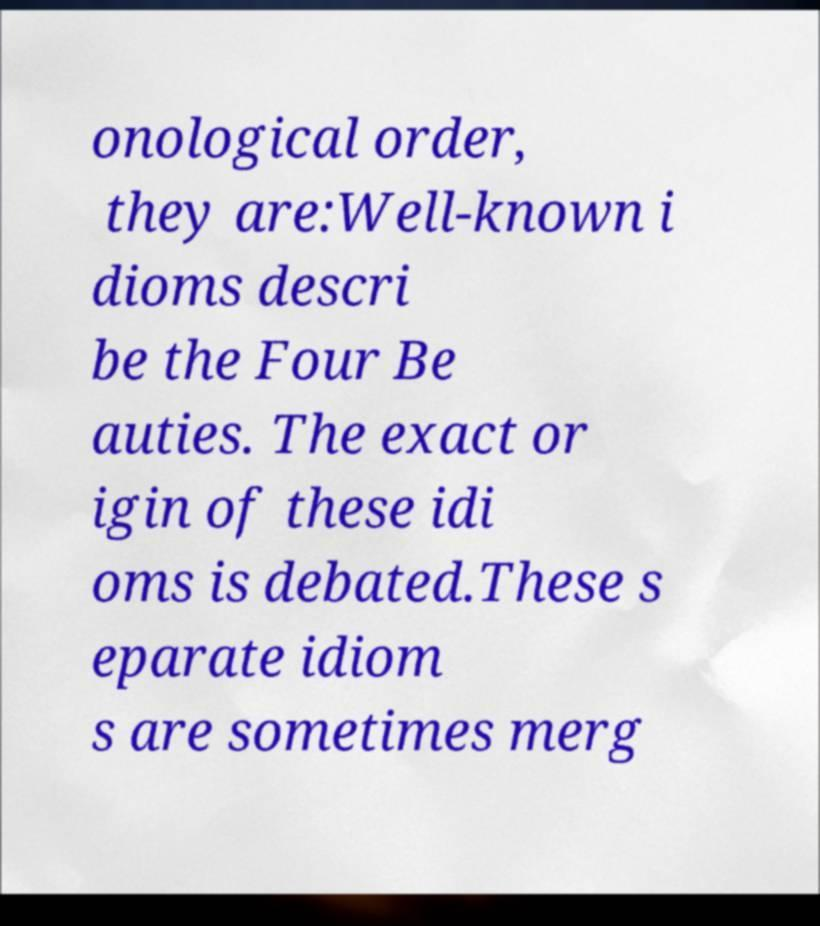Please identify and transcribe the text found in this image. onological order, they are:Well-known i dioms descri be the Four Be auties. The exact or igin of these idi oms is debated.These s eparate idiom s are sometimes merg 